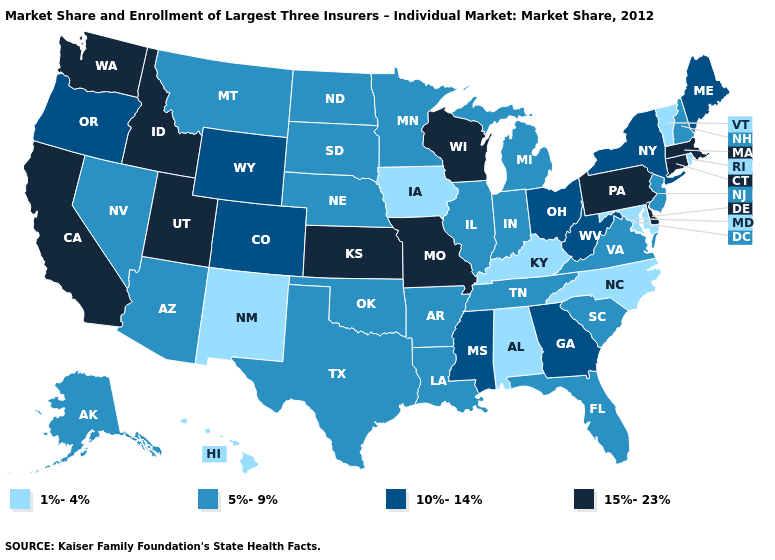Name the states that have a value in the range 1%-4%?
Answer briefly. Alabama, Hawaii, Iowa, Kentucky, Maryland, New Mexico, North Carolina, Rhode Island, Vermont. Does Indiana have a lower value than Wyoming?
Keep it brief. Yes. Name the states that have a value in the range 10%-14%?
Concise answer only. Colorado, Georgia, Maine, Mississippi, New York, Ohio, Oregon, West Virginia, Wyoming. How many symbols are there in the legend?
Keep it brief. 4. What is the value of West Virginia?
Give a very brief answer. 10%-14%. Does the map have missing data?
Be succinct. No. Does the first symbol in the legend represent the smallest category?
Write a very short answer. Yes. What is the value of Nevada?
Concise answer only. 5%-9%. What is the lowest value in states that border Maine?
Short answer required. 5%-9%. Name the states that have a value in the range 1%-4%?
Write a very short answer. Alabama, Hawaii, Iowa, Kentucky, Maryland, New Mexico, North Carolina, Rhode Island, Vermont. What is the highest value in the MidWest ?
Concise answer only. 15%-23%. What is the highest value in the USA?
Quick response, please. 15%-23%. Does California have the lowest value in the USA?
Short answer required. No. What is the value of Virginia?
Keep it brief. 5%-9%. Which states hav the highest value in the West?
Short answer required. California, Idaho, Utah, Washington. 